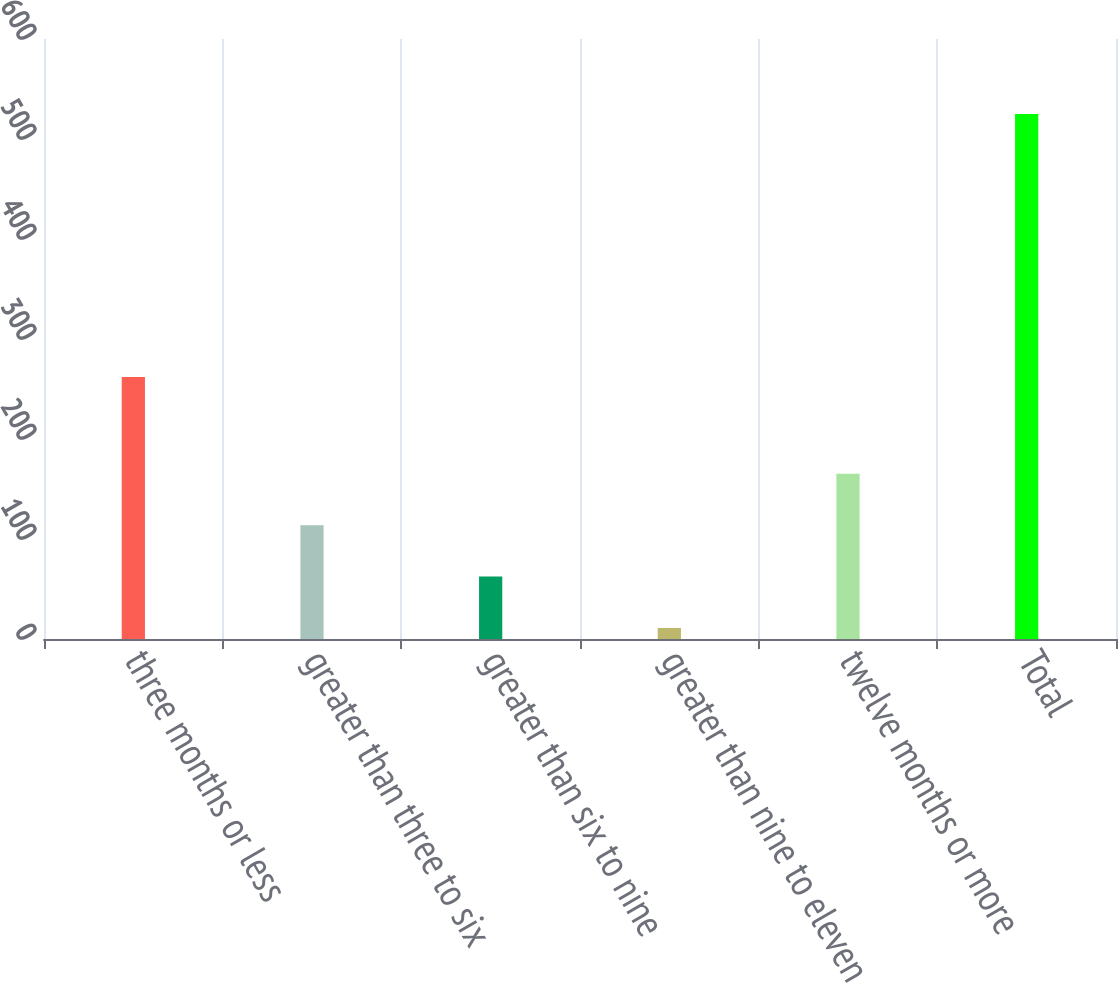Convert chart. <chart><loc_0><loc_0><loc_500><loc_500><bar_chart><fcel>three months or less<fcel>greater than three to six<fcel>greater than six to nine<fcel>greater than nine to eleven<fcel>twelve months or more<fcel>Total<nl><fcel>262<fcel>113.8<fcel>62.4<fcel>11<fcel>165.2<fcel>525<nl></chart> 